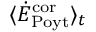Convert formula to latex. <formula><loc_0><loc_0><loc_500><loc_500>\langle \dot { E } _ { P o y t } ^ { c o r } \rangle _ { t }</formula> 